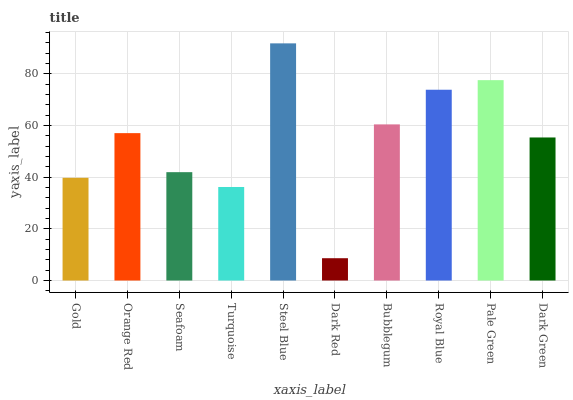Is Dark Red the minimum?
Answer yes or no. Yes. Is Steel Blue the maximum?
Answer yes or no. Yes. Is Orange Red the minimum?
Answer yes or no. No. Is Orange Red the maximum?
Answer yes or no. No. Is Orange Red greater than Gold?
Answer yes or no. Yes. Is Gold less than Orange Red?
Answer yes or no. Yes. Is Gold greater than Orange Red?
Answer yes or no. No. Is Orange Red less than Gold?
Answer yes or no. No. Is Orange Red the high median?
Answer yes or no. Yes. Is Dark Green the low median?
Answer yes or no. Yes. Is Pale Green the high median?
Answer yes or no. No. Is Bubblegum the low median?
Answer yes or no. No. 